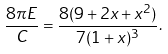<formula> <loc_0><loc_0><loc_500><loc_500>\frac { 8 \pi E } { C } = \frac { 8 ( 9 + 2 x + x ^ { 2 } ) } { 7 ( 1 + x ) ^ { 3 } } .</formula> 